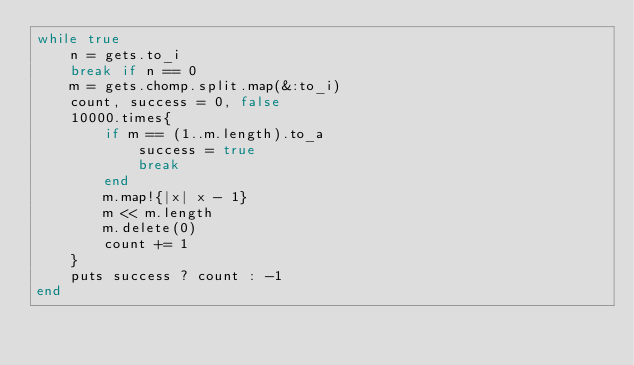<code> <loc_0><loc_0><loc_500><loc_500><_Ruby_>while true
    n = gets.to_i
    break if n == 0
    m = gets.chomp.split.map(&:to_i)
    count, success = 0, false
    10000.times{
        if m == (1..m.length).to_a
            success = true
            break
        end
        m.map!{|x| x - 1}
        m << m.length
        m.delete(0)
        count += 1
    }
    puts success ? count : -1
end
</code> 